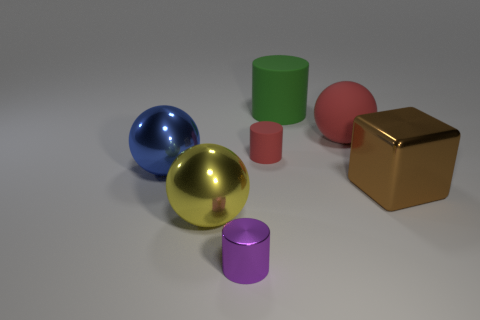Can you describe the material and appearance of the objects furthest to the right? The object furthest to the right appears to have a shiny, reflective gold surface, suggesting it is metallic. It has a cubic shape with distinct edges and flat surfaces that create a sense of solidity and weight. Is the material real gold, or could it be just painted to look like this? Without additional information, it is difficult to ascertain the true material composition from this image alone. However, the object's appearance is consistent with a gold paint finish typically used to simulate the appearance of gold. 